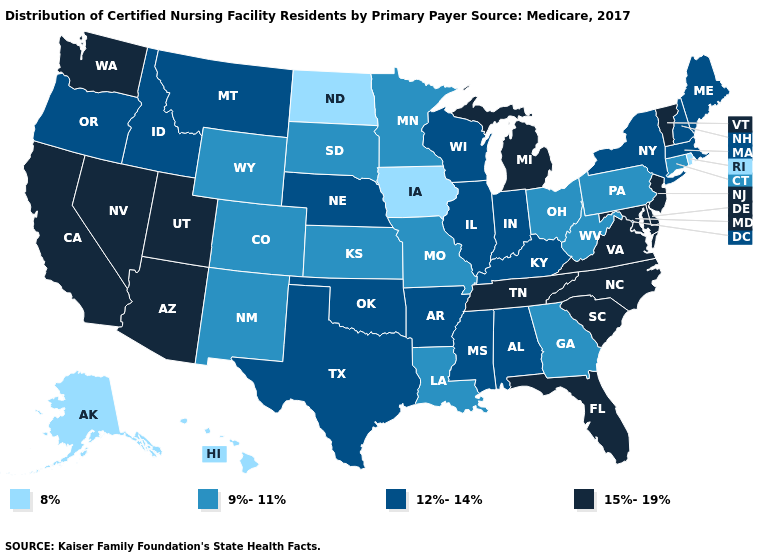Which states have the lowest value in the West?
Write a very short answer. Alaska, Hawaii. What is the value of Delaware?
Short answer required. 15%-19%. What is the highest value in the South ?
Write a very short answer. 15%-19%. What is the value of South Carolina?
Give a very brief answer. 15%-19%. Which states hav the highest value in the West?
Short answer required. Arizona, California, Nevada, Utah, Washington. What is the value of Hawaii?
Answer briefly. 8%. Among the states that border Arizona , does New Mexico have the lowest value?
Short answer required. Yes. Name the states that have a value in the range 9%-11%?
Give a very brief answer. Colorado, Connecticut, Georgia, Kansas, Louisiana, Minnesota, Missouri, New Mexico, Ohio, Pennsylvania, South Dakota, West Virginia, Wyoming. Which states have the lowest value in the USA?
Short answer required. Alaska, Hawaii, Iowa, North Dakota, Rhode Island. Name the states that have a value in the range 15%-19%?
Give a very brief answer. Arizona, California, Delaware, Florida, Maryland, Michigan, Nevada, New Jersey, North Carolina, South Carolina, Tennessee, Utah, Vermont, Virginia, Washington. Does Wyoming have the same value as Minnesota?
Quick response, please. Yes. What is the highest value in the USA?
Keep it brief. 15%-19%. Among the states that border Maryland , does Virginia have the lowest value?
Keep it brief. No. Name the states that have a value in the range 9%-11%?
Be succinct. Colorado, Connecticut, Georgia, Kansas, Louisiana, Minnesota, Missouri, New Mexico, Ohio, Pennsylvania, South Dakota, West Virginia, Wyoming. 